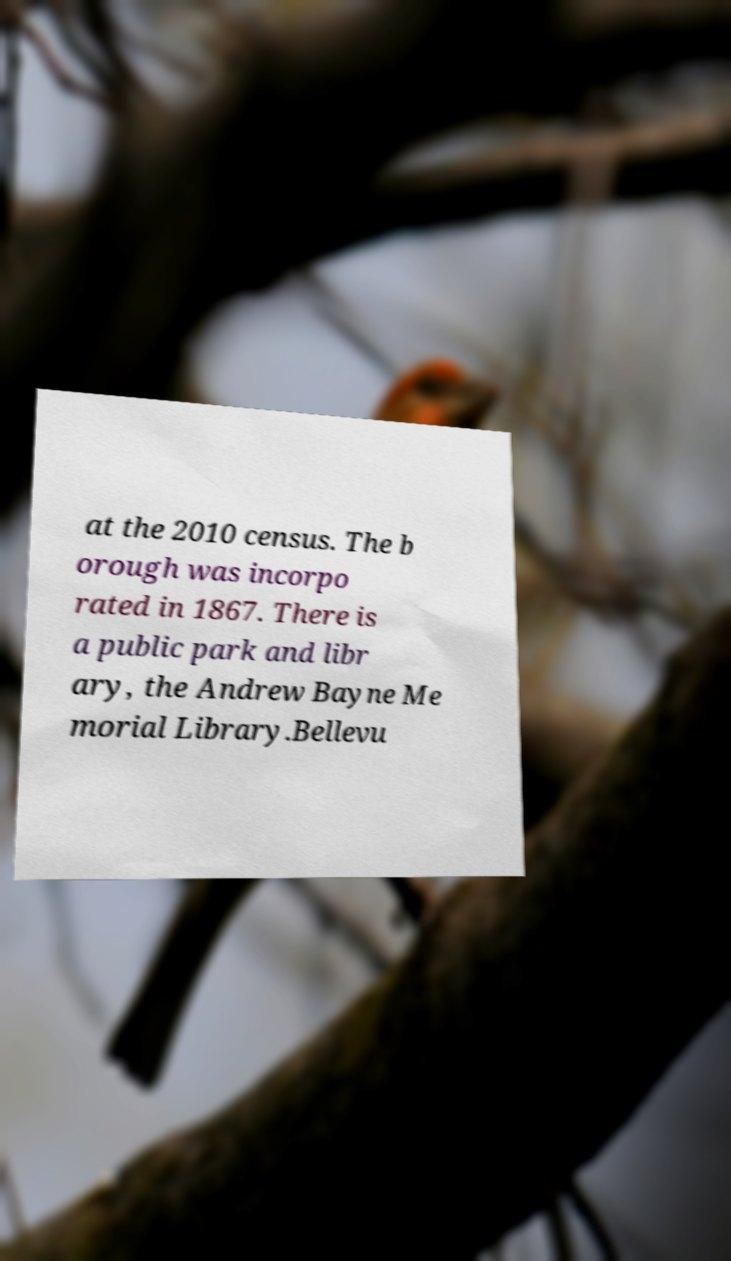For documentation purposes, I need the text within this image transcribed. Could you provide that? at the 2010 census. The b orough was incorpo rated in 1867. There is a public park and libr ary, the Andrew Bayne Me morial Library.Bellevu 